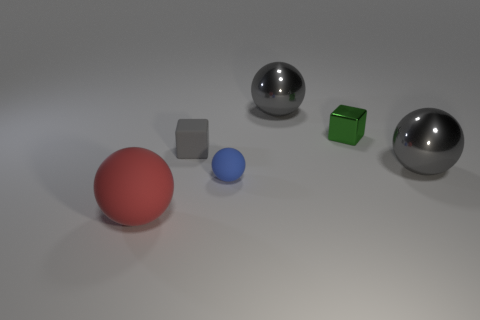How many other things are there of the same material as the green cube?
Offer a very short reply. 2. What is the color of the tiny rubber thing on the left side of the rubber sphere behind the large red rubber thing in front of the tiny green thing?
Keep it short and to the point. Gray. There is a object that is in front of the green metallic cube and on the right side of the tiny blue ball; what is its shape?
Offer a terse response. Sphere. The ball that is to the left of the rubber ball behind the large red matte thing is what color?
Provide a short and direct response. Red. There is a big gray metal object that is behind the large gray metal sphere that is to the right of the gray metal sphere behind the green metallic cube; what is its shape?
Offer a very short reply. Sphere. There is a object that is both left of the blue thing and behind the red rubber thing; how big is it?
Provide a succinct answer. Small. What number of cubes have the same color as the small metallic thing?
Your response must be concise. 0. What material is the green thing?
Your answer should be compact. Metal. Are the big thing that is behind the small metallic block and the tiny sphere made of the same material?
Ensure brevity in your answer.  No. There is a tiny object that is behind the small gray cube; what shape is it?
Your answer should be compact. Cube. 